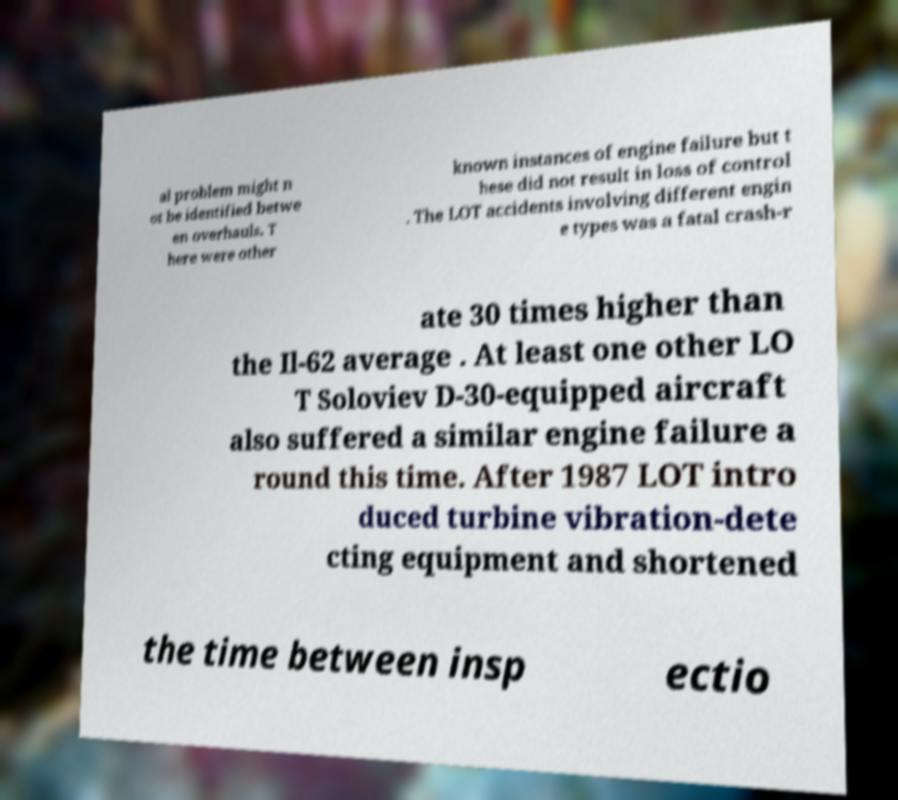Can you read and provide the text displayed in the image?This photo seems to have some interesting text. Can you extract and type it out for me? al problem might n ot be identified betwe en overhauls. T here were other known instances of engine failure but t hese did not result in loss of control . The LOT accidents involving different engin e types was a fatal crash-r ate 30 times higher than the Il-62 average . At least one other LO T Soloviev D-30-equipped aircraft also suffered a similar engine failure a round this time. After 1987 LOT intro duced turbine vibration-dete cting equipment and shortened the time between insp ectio 